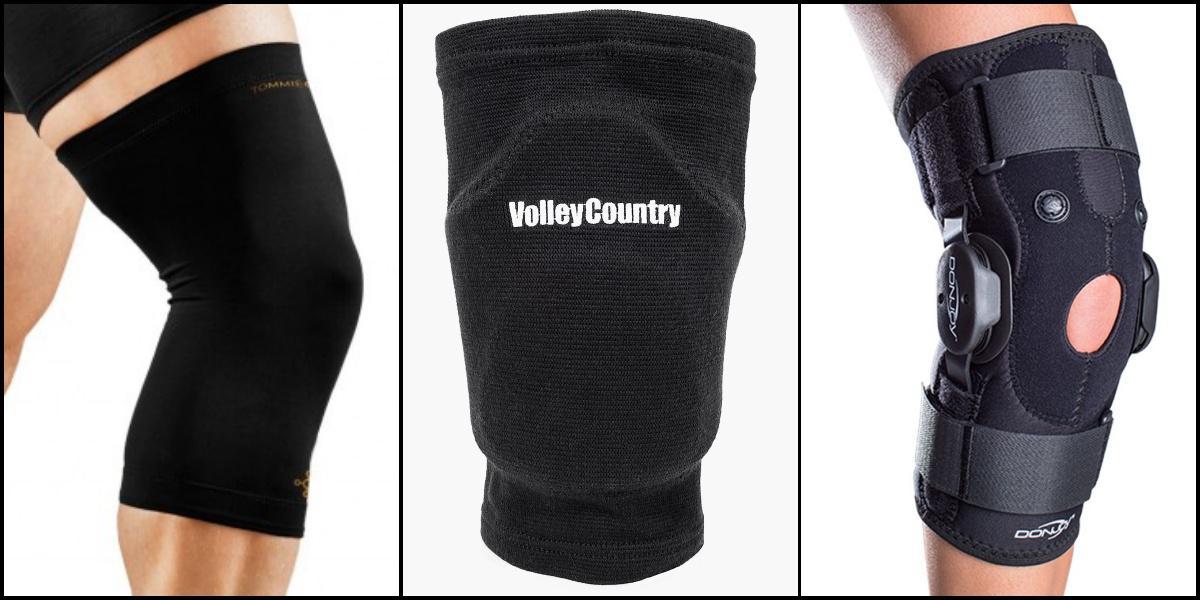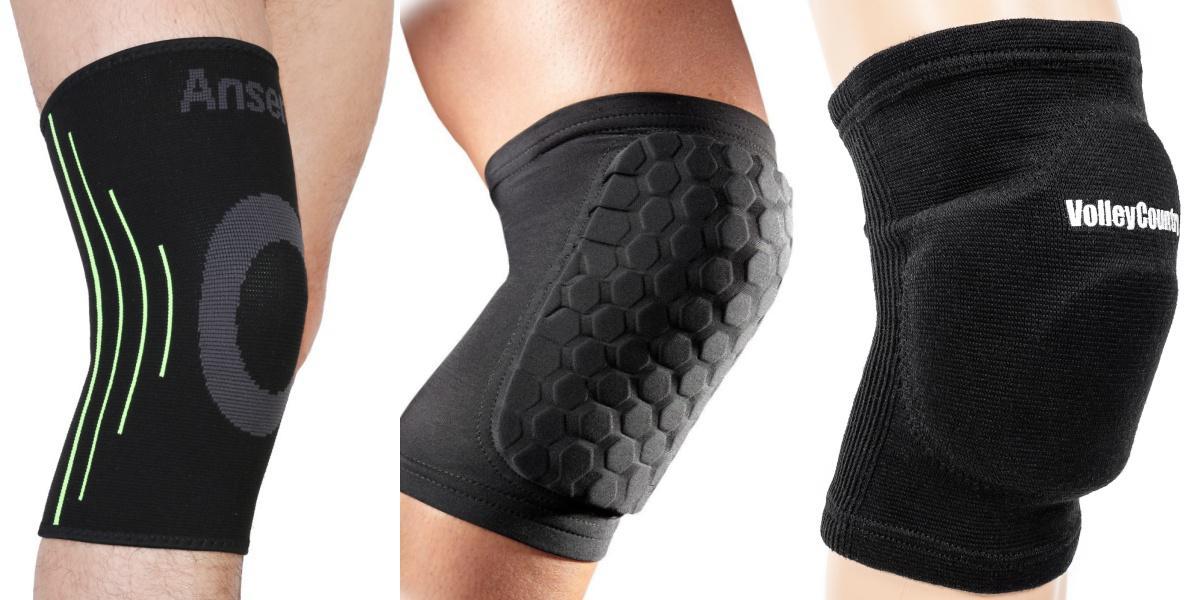The first image is the image on the left, the second image is the image on the right. For the images displayed, is the sentence "In total, there are 4 knees covered by black knee guards." factually correct? Answer yes or no. No. The first image is the image on the left, the second image is the image on the right. Examine the images to the left and right. Is the description "A white kneepad is next to a black kneepad in at least one of the images." accurate? Answer yes or no. No. The first image is the image on the left, the second image is the image on the right. For the images shown, is this caption "There are two sets of matching knee pads being worn by two people." true? Answer yes or no. No. The first image is the image on the left, the second image is the image on the right. For the images shown, is this caption "The right image contains exactly two black knee pads." true? Answer yes or no. No. 